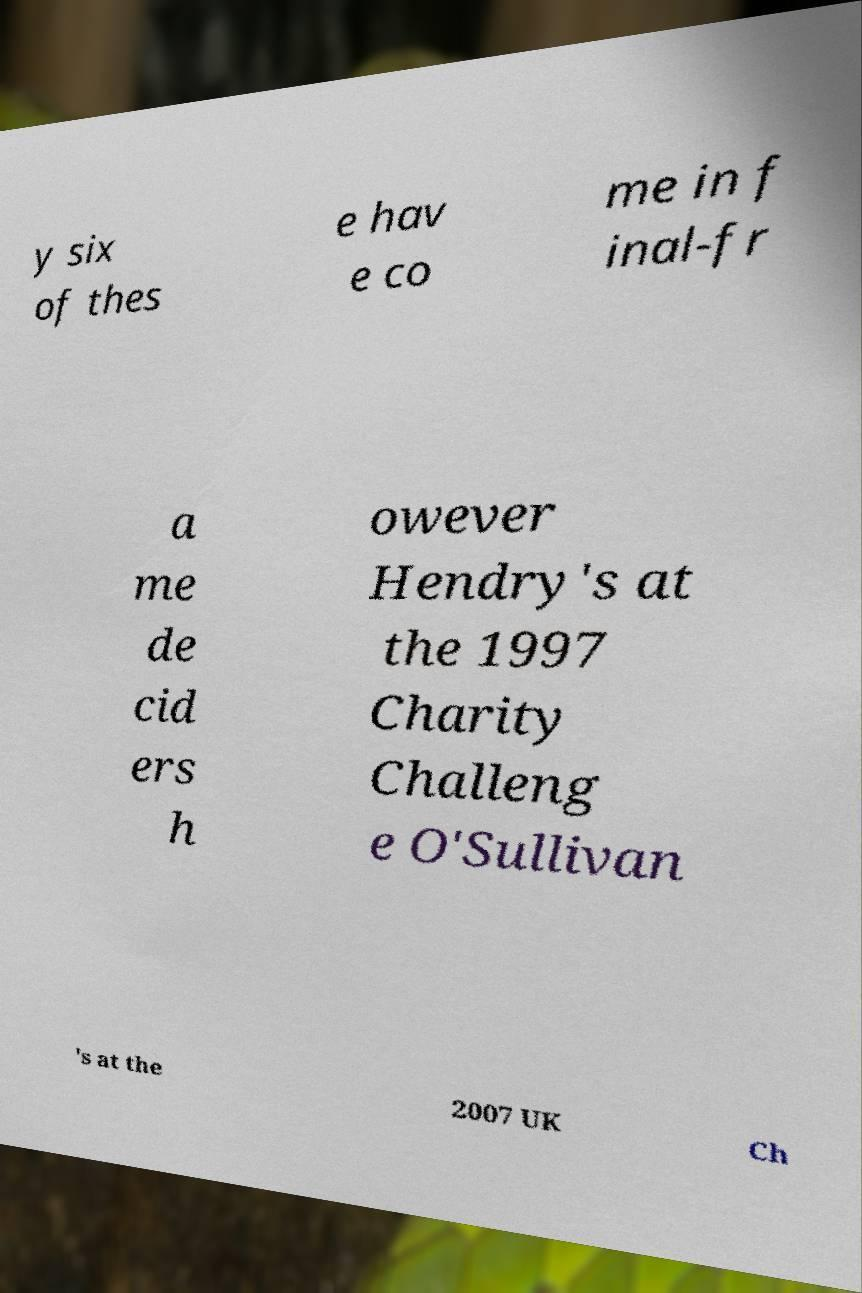I need the written content from this picture converted into text. Can you do that? y six of thes e hav e co me in f inal-fr a me de cid ers h owever Hendry's at the 1997 Charity Challeng e O'Sullivan 's at the 2007 UK Ch 